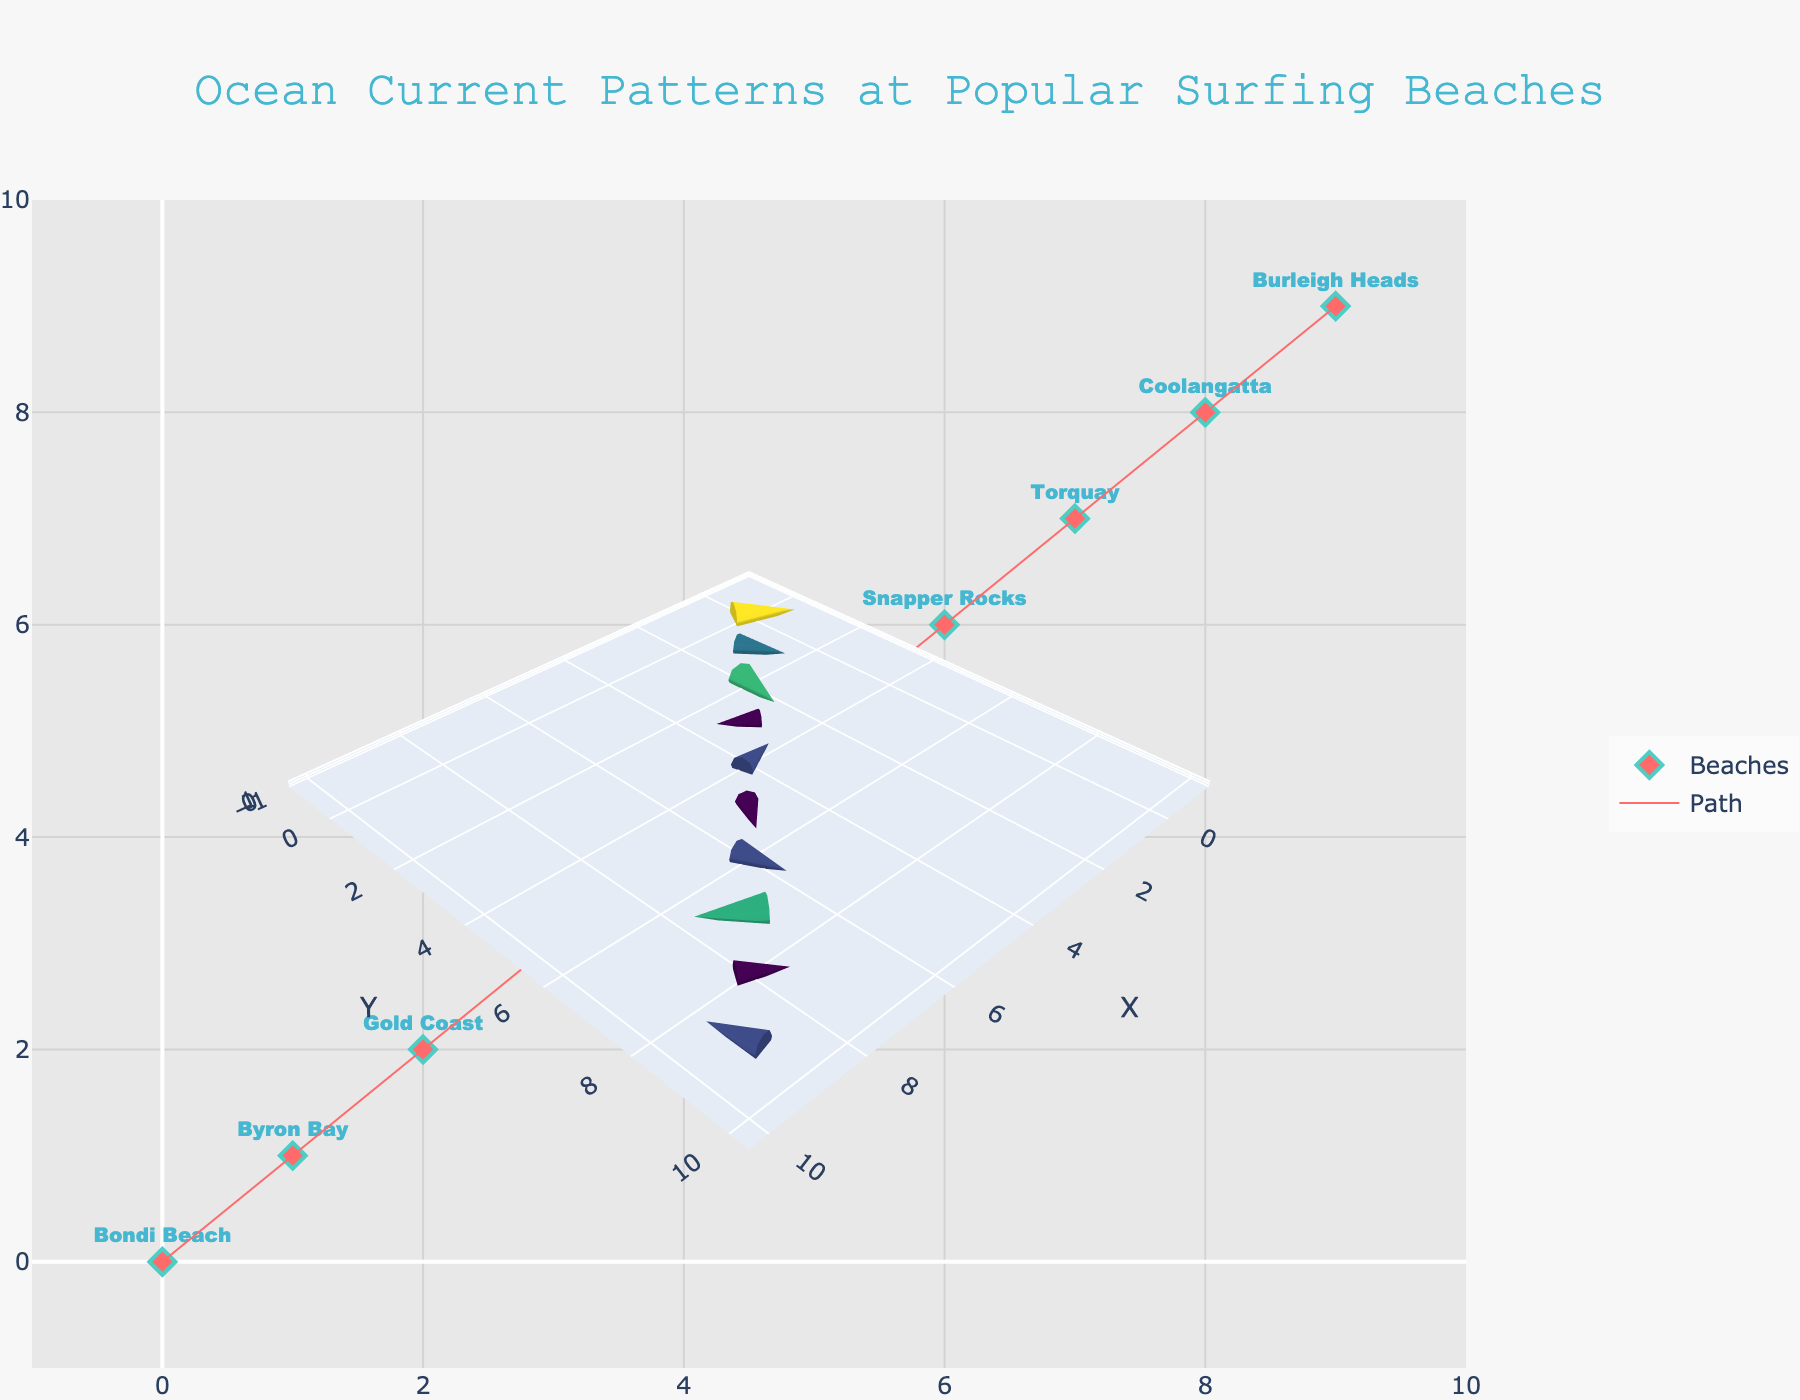What is the title of the figure? The title is usually at the top of the figure in larger, bold text. In this case, it reads "Ocean Current Patterns at Popular Surfing Beaches".
Answer: Ocean Current Patterns at Popular Surfing Beaches What do the diamond markers represent? The key to understanding this is that the diamond markers are labeled with the names of beaches. Hence, the diamond markers represent the popular surfing beaches.
Answer: Popular surfing beaches What is the color of the lines representing the path? By observing the color of the lines that connect the markers, one can see they are colored in a shade of red or pink.
Answer: Red/Pink Which beach shows the strongest current? To determine this, one needs to identify the beach with the longest arrow, which can be traced back to its textual label. The beach with the longest vector is Gold Coast.
Answer: Gold Coast How many data points (beaches) are there in the figure? Count the number of diamond markers labeled with beach names. There are 10 markers labeled with different beach names.
Answer: 10 Which beach has a current direction pointing to the upper left? Current direction pointing to the upper left would imply a negative U value and a positive V value. Bondi Beach fits this description.
Answer: Bondi Beach Which beach has the smallest U component in its ocean current? The beach with the smallest (most negative) U value can be found by comparing all U values. Margaret River has the smallest U value of -0.4.
Answer: Margaret River Which beach's current direction is pointing downward? A downward direction means a negative V value. Checking for beaches with negative V values, we find Bells Beach, Torquay, and Burleigh Heads.
Answer: Bells Beach, Torquay, Burleigh Heads What is the general direction of the current at Bells Beach? Look at the vector at the position of Bells Beach. The U and V values are (0.3, -0.2) indicating it's generally pointing to the right and slightly downward.
Answer: Right and down Which beach has currents flowing in opposite directions? Currents in opposite directions imply one beach has a positive U component while another has a negative U component, and similarly for the V component. Gold Coast has a current with positive U, while Margaret River has a current with negative U.
Answer: Gold Coast and Margaret River 